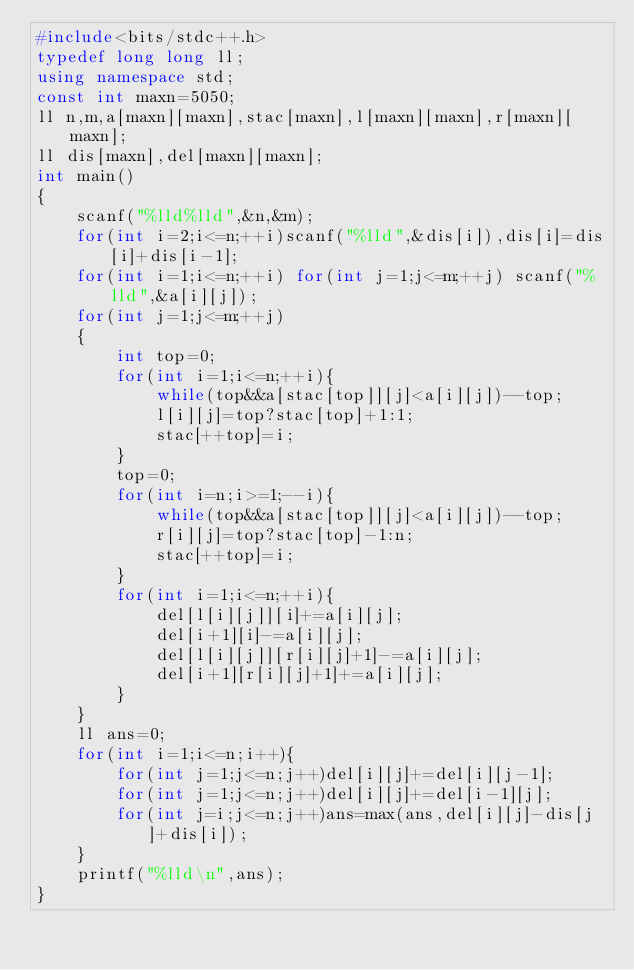<code> <loc_0><loc_0><loc_500><loc_500><_C++_>#include<bits/stdc++.h>
typedef long long ll;
using namespace std;
const int maxn=5050;
ll n,m,a[maxn][maxn],stac[maxn],l[maxn][maxn],r[maxn][maxn];
ll dis[maxn],del[maxn][maxn];
int main()
{
	scanf("%lld%lld",&n,&m);
	for(int i=2;i<=n;++i)scanf("%lld",&dis[i]),dis[i]=dis[i]+dis[i-1];
	for(int i=1;i<=n;++i) for(int j=1;j<=m;++j) scanf("%lld",&a[i][j]);
	for(int j=1;j<=m;++j)
	{
		int top=0;
		for(int i=1;i<=n;++i){
			while(top&&a[stac[top]][j]<a[i][j])--top;
			l[i][j]=top?stac[top]+1:1;
			stac[++top]=i;
		}
		top=0;
		for(int i=n;i>=1;--i){
			while(top&&a[stac[top]][j]<a[i][j])--top;
			r[i][j]=top?stac[top]-1:n;
			stac[++top]=i;
		}
		for(int i=1;i<=n;++i){
			del[l[i][j]][i]+=a[i][j];
			del[i+1][i]-=a[i][j];
			del[l[i][j]][r[i][j]+1]-=a[i][j];
			del[i+1][r[i][j]+1]+=a[i][j];
		}
	}
	ll ans=0;
	for(int i=1;i<=n;i++){
		for(int j=1;j<=n;j++)del[i][j]+=del[i][j-1];
		for(int j=1;j<=n;j++)del[i][j]+=del[i-1][j];
		for(int j=i;j<=n;j++)ans=max(ans,del[i][j]-dis[j]+dis[i]); 
	} 
	printf("%lld\n",ans); 
}
</code> 